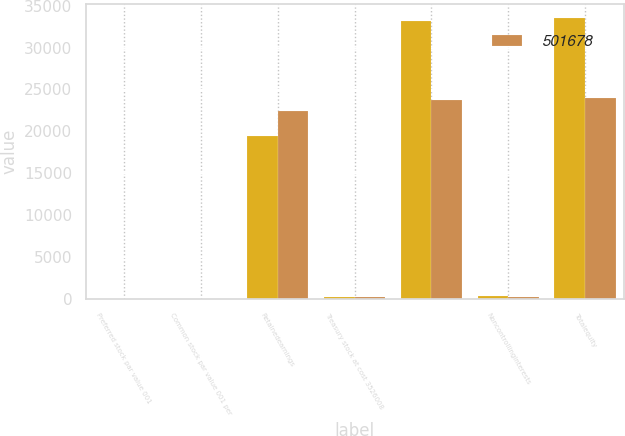Convert chart. <chart><loc_0><loc_0><loc_500><loc_500><stacked_bar_chart><ecel><fcel>Preferred stock par value 001<fcel>Common stock par value 001 per<fcel>Retainedearnings<fcel>Treasury stock at cost 3526008<fcel>Unnamed: 5<fcel>Noncontrollinginterests<fcel>Totalequity<nl><fcel>nan<fcel>1<fcel>8<fcel>19501<fcel>190<fcel>33121<fcel>377<fcel>33498<nl><fcel>501678<fcel>1<fcel>8<fcel>22403<fcel>236<fcel>23734<fcel>251<fcel>23985<nl></chart> 